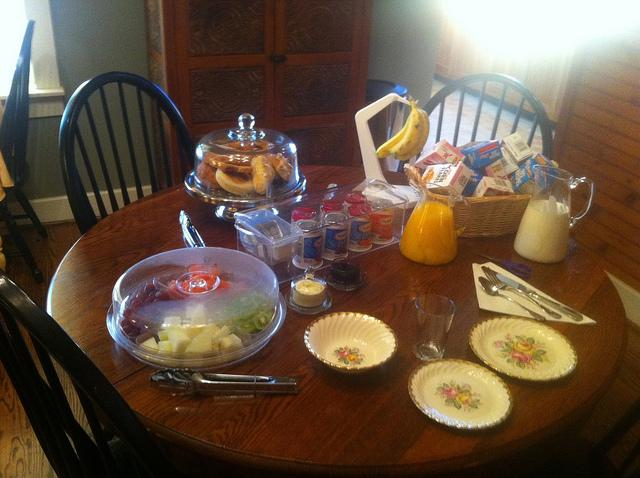What are the plastic lids used for when covering these trays of food?

Choices:
A) transport
B) heat
C) cold
D) protection protection 